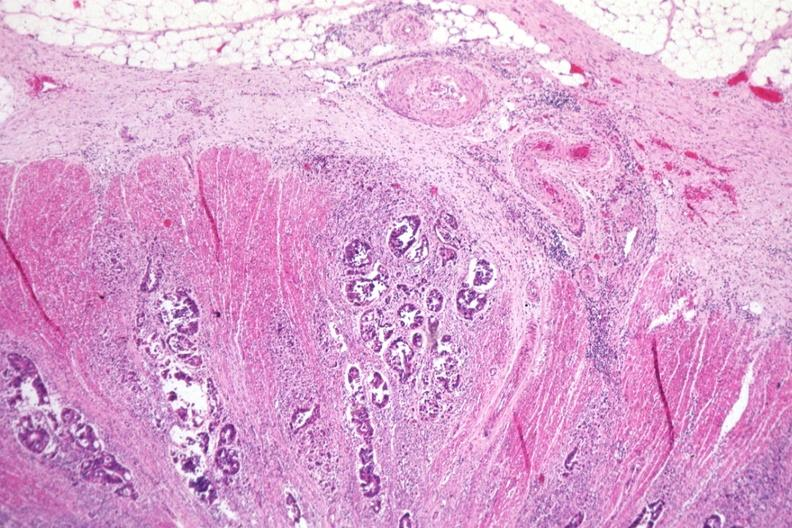s gastrointestinal present?
Answer the question using a single word or phrase. Yes 